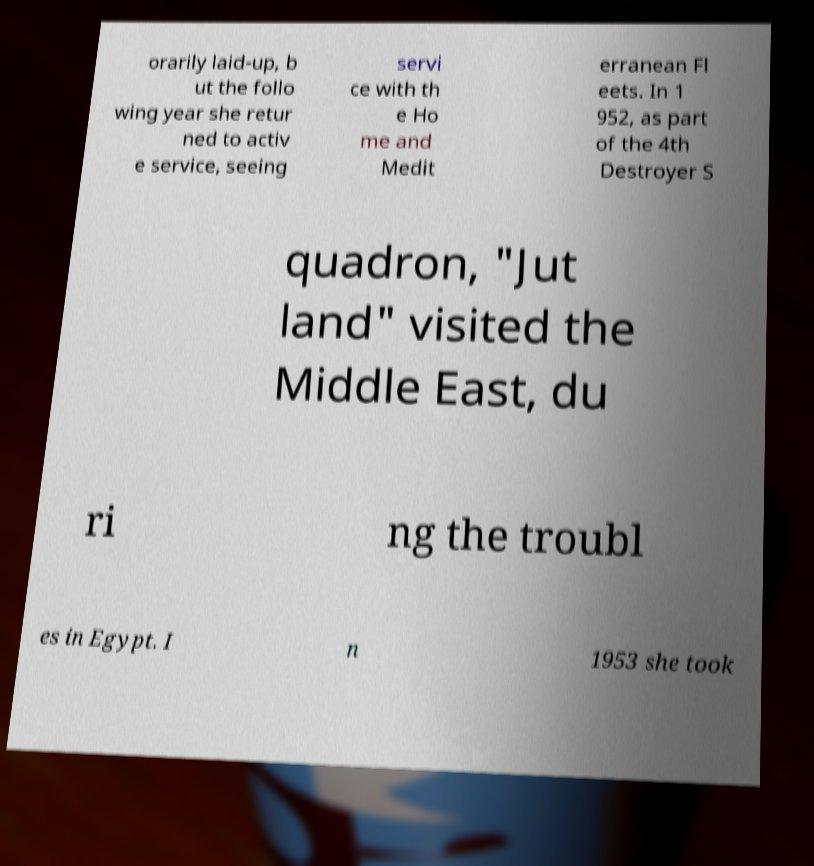Can you accurately transcribe the text from the provided image for me? orarily laid-up, b ut the follo wing year she retur ned to activ e service, seeing servi ce with th e Ho me and Medit erranean Fl eets. In 1 952, as part of the 4th Destroyer S quadron, "Jut land" visited the Middle East, du ri ng the troubl es in Egypt. I n 1953 she took 